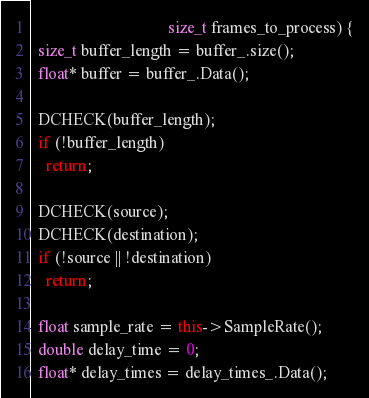Convert code to text. <code><loc_0><loc_0><loc_500><loc_500><_C++_>                                  size_t frames_to_process) {
  size_t buffer_length = buffer_.size();
  float* buffer = buffer_.Data();

  DCHECK(buffer_length);
  if (!buffer_length)
    return;

  DCHECK(source);
  DCHECK(destination);
  if (!source || !destination)
    return;

  float sample_rate = this->SampleRate();
  double delay_time = 0;
  float* delay_times = delay_times_.Data();</code> 